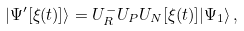<formula> <loc_0><loc_0><loc_500><loc_500>| \Psi ^ { \prime } [ \xi ( t ) ] \rangle = U _ { R } ^ { - } U _ { P } U _ { N } [ \xi ( t ) ] | \Psi _ { 1 } \rangle \, ,</formula> 